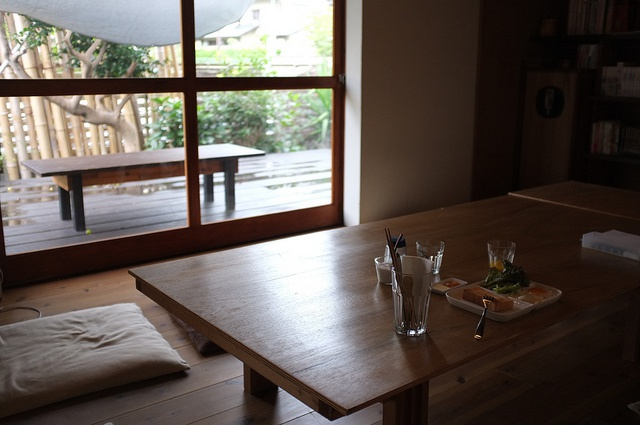Describe the objects in this image and their specific colors. I can see dining table in darkgray, black, white, and gray tones, bench in darkgray, black, maroon, and lavender tones, book in darkgray and black tones, cup in darkgray, black, and gray tones, and book in black and darkgray tones in this image. 